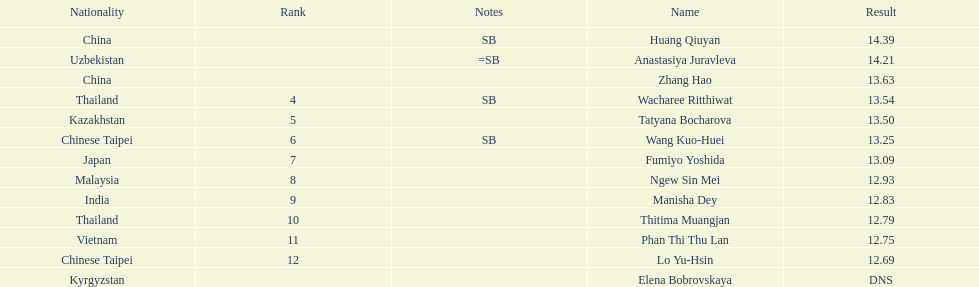How many athletes had a better result than tatyana bocharova? 4. 